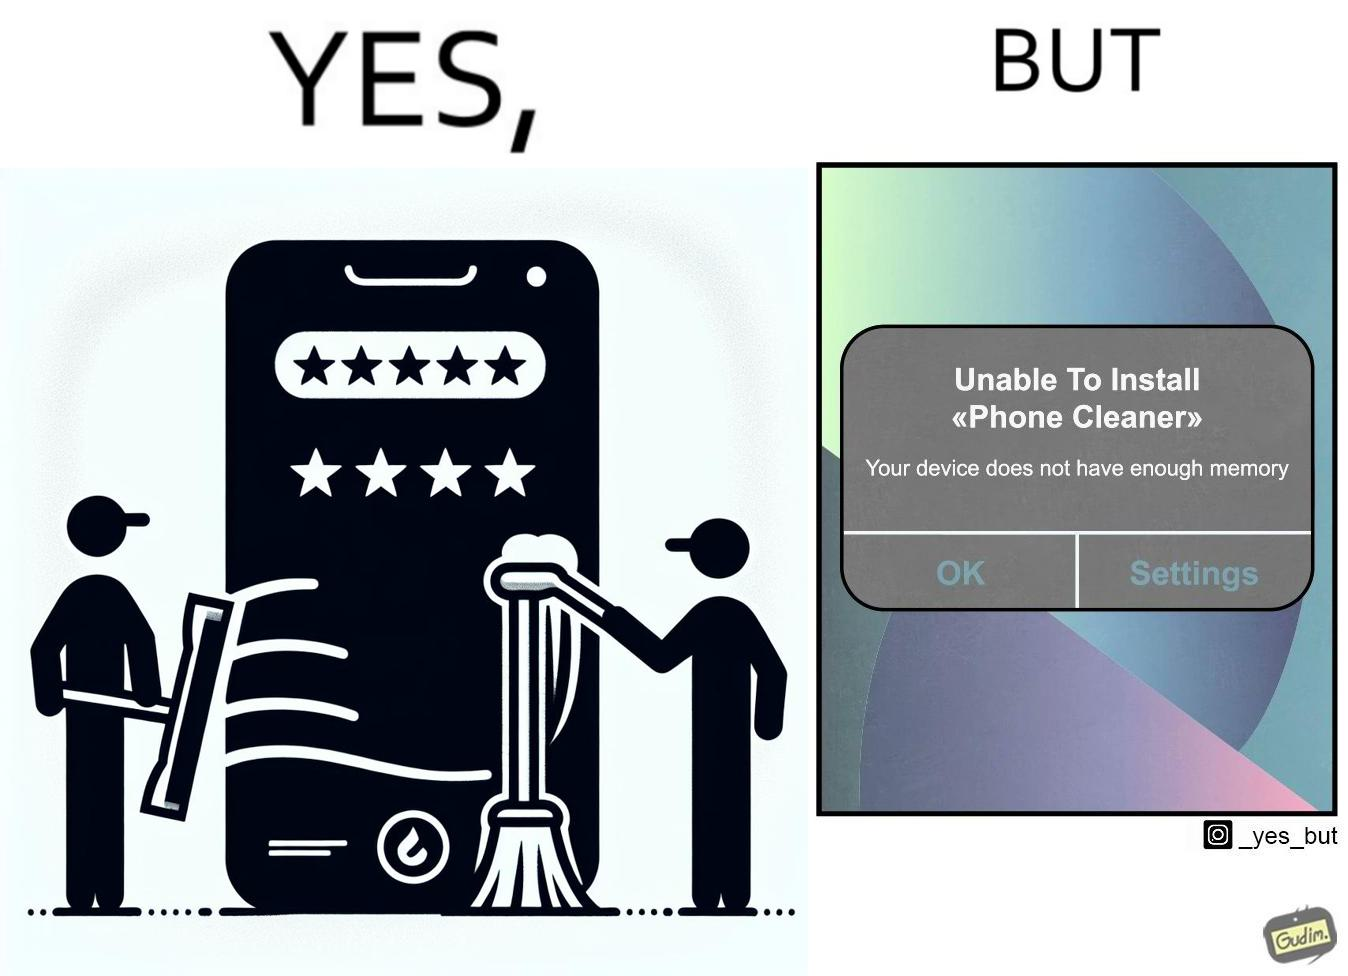Provide a description of this image. The image is ironical, as to clear the phone's memory using phone cleaner app, one has to install it, but that is not possible in turn due to the phone memory being full. 